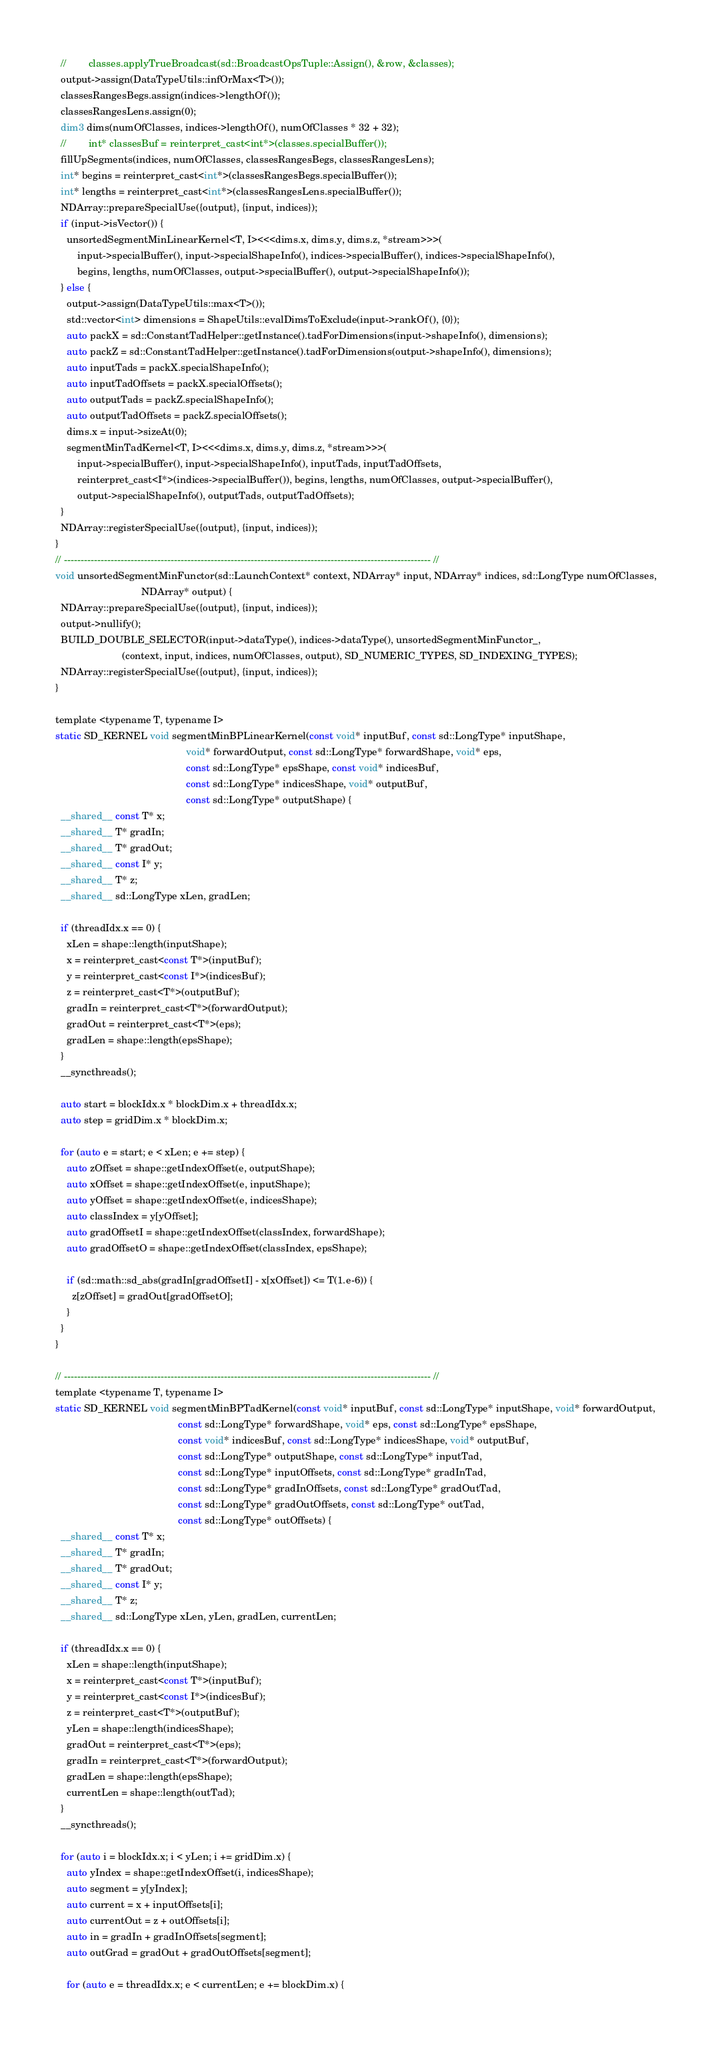Convert code to text. <code><loc_0><loc_0><loc_500><loc_500><_Cuda_>  //        classes.applyTrueBroadcast(sd::BroadcastOpsTuple::Assign(), &row, &classes);
  output->assign(DataTypeUtils::infOrMax<T>());
  classesRangesBegs.assign(indices->lengthOf());
  classesRangesLens.assign(0);
  dim3 dims(numOfClasses, indices->lengthOf(), numOfClasses * 32 + 32);
  //        int* classesBuf = reinterpret_cast<int*>(classes.specialBuffer());
  fillUpSegments(indices, numOfClasses, classesRangesBegs, classesRangesLens);
  int* begins = reinterpret_cast<int*>(classesRangesBegs.specialBuffer());
  int* lengths = reinterpret_cast<int*>(classesRangesLens.specialBuffer());
  NDArray::prepareSpecialUse({output}, {input, indices});
  if (input->isVector()) {
    unsortedSegmentMinLinearKernel<T, I><<<dims.x, dims.y, dims.z, *stream>>>(
        input->specialBuffer(), input->specialShapeInfo(), indices->specialBuffer(), indices->specialShapeInfo(),
        begins, lengths, numOfClasses, output->specialBuffer(), output->specialShapeInfo());
  } else {
    output->assign(DataTypeUtils::max<T>());
    std::vector<int> dimensions = ShapeUtils::evalDimsToExclude(input->rankOf(), {0});
    auto packX = sd::ConstantTadHelper::getInstance().tadForDimensions(input->shapeInfo(), dimensions);
    auto packZ = sd::ConstantTadHelper::getInstance().tadForDimensions(output->shapeInfo(), dimensions);
    auto inputTads = packX.specialShapeInfo();
    auto inputTadOffsets = packX.specialOffsets();
    auto outputTads = packZ.specialShapeInfo();
    auto outputTadOffsets = packZ.specialOffsets();
    dims.x = input->sizeAt(0);
    segmentMinTadKernel<T, I><<<dims.x, dims.y, dims.z, *stream>>>(
        input->specialBuffer(), input->specialShapeInfo(), inputTads, inputTadOffsets,
        reinterpret_cast<I*>(indices->specialBuffer()), begins, lengths, numOfClasses, output->specialBuffer(),
        output->specialShapeInfo(), outputTads, outputTadOffsets);
  }
  NDArray::registerSpecialUse({output}, {input, indices});
}
// -------------------------------------------------------------------------------------------------------------- //
void unsortedSegmentMinFunctor(sd::LaunchContext* context, NDArray* input, NDArray* indices, sd::LongType numOfClasses,
                               NDArray* output) {
  NDArray::prepareSpecialUse({output}, {input, indices});
  output->nullify();
  BUILD_DOUBLE_SELECTOR(input->dataType(), indices->dataType(), unsortedSegmentMinFunctor_,
                        (context, input, indices, numOfClasses, output), SD_NUMERIC_TYPES, SD_INDEXING_TYPES);
  NDArray::registerSpecialUse({output}, {input, indices});
}

template <typename T, typename I>
static SD_KERNEL void segmentMinBPLinearKernel(const void* inputBuf, const sd::LongType* inputShape,
                                               void* forwardOutput, const sd::LongType* forwardShape, void* eps,
                                               const sd::LongType* epsShape, const void* indicesBuf,
                                               const sd::LongType* indicesShape, void* outputBuf,
                                               const sd::LongType* outputShape) {
  __shared__ const T* x;
  __shared__ T* gradIn;
  __shared__ T* gradOut;
  __shared__ const I* y;
  __shared__ T* z;
  __shared__ sd::LongType xLen, gradLen;

  if (threadIdx.x == 0) {
    xLen = shape::length(inputShape);
    x = reinterpret_cast<const T*>(inputBuf);
    y = reinterpret_cast<const I*>(indicesBuf);
    z = reinterpret_cast<T*>(outputBuf);
    gradIn = reinterpret_cast<T*>(forwardOutput);
    gradOut = reinterpret_cast<T*>(eps);
    gradLen = shape::length(epsShape);
  }
  __syncthreads();

  auto start = blockIdx.x * blockDim.x + threadIdx.x;
  auto step = gridDim.x * blockDim.x;

  for (auto e = start; e < xLen; e += step) {
    auto zOffset = shape::getIndexOffset(e, outputShape);
    auto xOffset = shape::getIndexOffset(e, inputShape);
    auto yOffset = shape::getIndexOffset(e, indicesShape);
    auto classIndex = y[yOffset];
    auto gradOffsetI = shape::getIndexOffset(classIndex, forwardShape);
    auto gradOffsetO = shape::getIndexOffset(classIndex, epsShape);

    if (sd::math::sd_abs(gradIn[gradOffsetI] - x[xOffset]) <= T(1.e-6)) {
      z[zOffset] = gradOut[gradOffsetO];
    }
  }
}

// -------------------------------------------------------------------------------------------------------------- //
template <typename T, typename I>
static SD_KERNEL void segmentMinBPTadKernel(const void* inputBuf, const sd::LongType* inputShape, void* forwardOutput,
                                            const sd::LongType* forwardShape, void* eps, const sd::LongType* epsShape,
                                            const void* indicesBuf, const sd::LongType* indicesShape, void* outputBuf,
                                            const sd::LongType* outputShape, const sd::LongType* inputTad,
                                            const sd::LongType* inputOffsets, const sd::LongType* gradInTad,
                                            const sd::LongType* gradInOffsets, const sd::LongType* gradOutTad,
                                            const sd::LongType* gradOutOffsets, const sd::LongType* outTad,
                                            const sd::LongType* outOffsets) {
  __shared__ const T* x;
  __shared__ T* gradIn;
  __shared__ T* gradOut;
  __shared__ const I* y;
  __shared__ T* z;
  __shared__ sd::LongType xLen, yLen, gradLen, currentLen;

  if (threadIdx.x == 0) {
    xLen = shape::length(inputShape);
    x = reinterpret_cast<const T*>(inputBuf);
    y = reinterpret_cast<const I*>(indicesBuf);
    z = reinterpret_cast<T*>(outputBuf);
    yLen = shape::length(indicesShape);
    gradOut = reinterpret_cast<T*>(eps);
    gradIn = reinterpret_cast<T*>(forwardOutput);
    gradLen = shape::length(epsShape);
    currentLen = shape::length(outTad);
  }
  __syncthreads();

  for (auto i = blockIdx.x; i < yLen; i += gridDim.x) {
    auto yIndex = shape::getIndexOffset(i, indicesShape);
    auto segment = y[yIndex];
    auto current = x + inputOffsets[i];
    auto currentOut = z + outOffsets[i];
    auto in = gradIn + gradInOffsets[segment];
    auto outGrad = gradOut + gradOutOffsets[segment];

    for (auto e = threadIdx.x; e < currentLen; e += blockDim.x) {</code> 